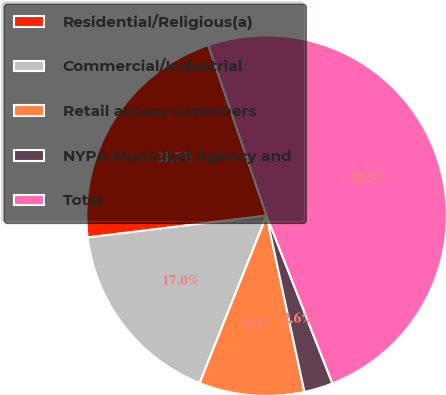Convert chart to OTSL. <chart><loc_0><loc_0><loc_500><loc_500><pie_chart><fcel>Residential/Religious(a)<fcel>Commercial/Industrial<fcel>Retail access customers<fcel>NYPA Municipal Agency and<fcel>Total<nl><fcel>21.69%<fcel>17.02%<fcel>9.43%<fcel>2.58%<fcel>49.29%<nl></chart> 